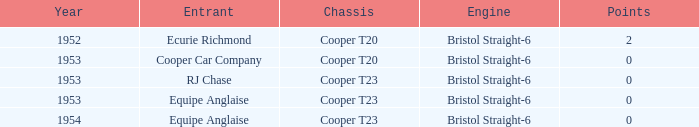How many years had more than 0 points? 1952.0. 